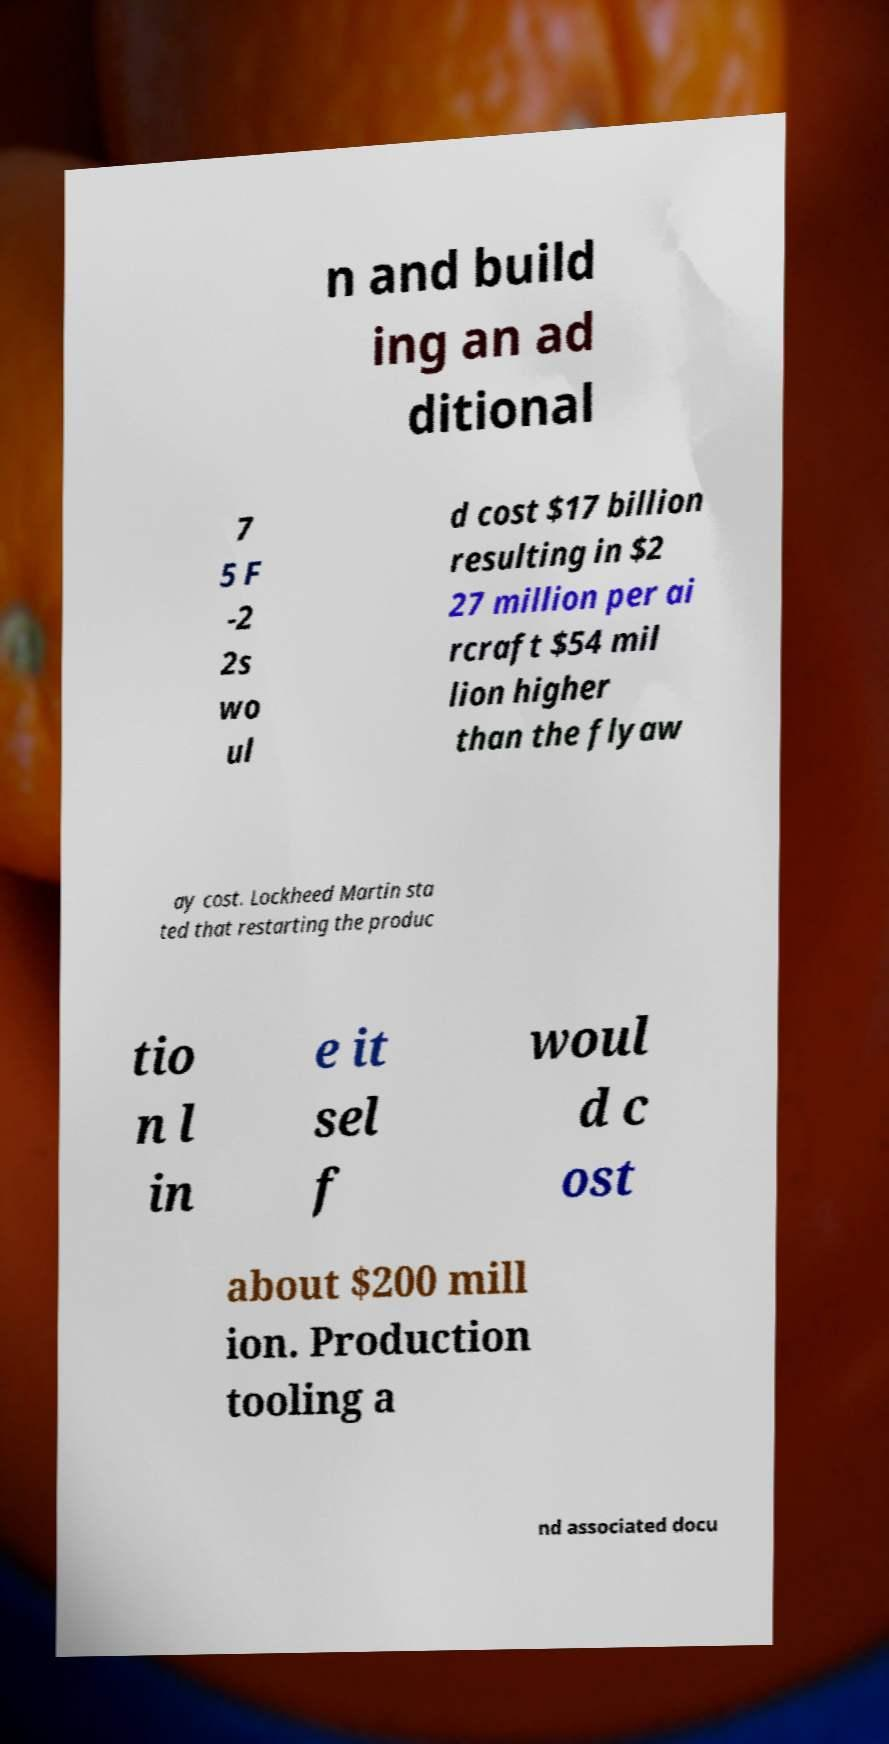For documentation purposes, I need the text within this image transcribed. Could you provide that? n and build ing an ad ditional 7 5 F -2 2s wo ul d cost $17 billion resulting in $2 27 million per ai rcraft $54 mil lion higher than the flyaw ay cost. Lockheed Martin sta ted that restarting the produc tio n l in e it sel f woul d c ost about $200 mill ion. Production tooling a nd associated docu 